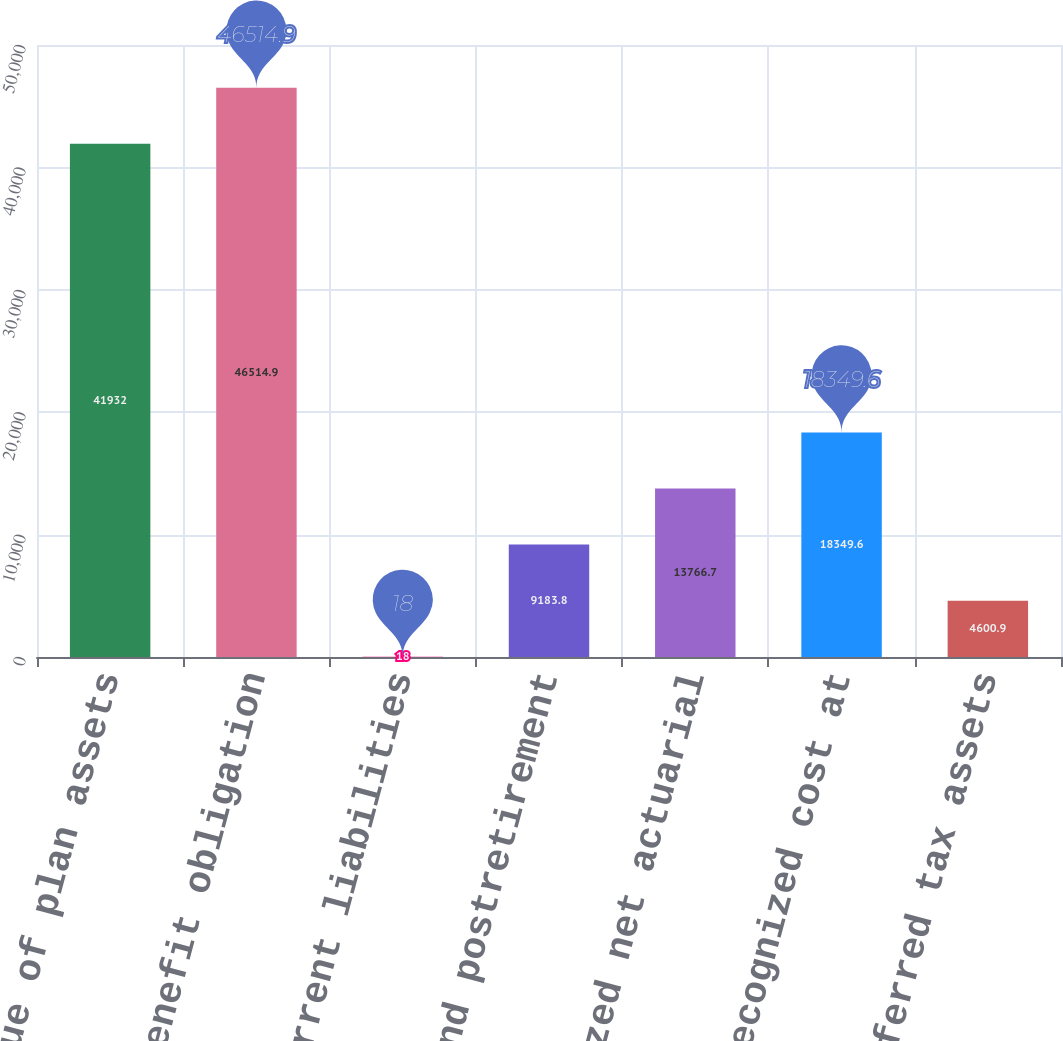Convert chart. <chart><loc_0><loc_0><loc_500><loc_500><bar_chart><fcel>Fair value of plan assets<fcel>Benefit obligation<fcel>Other current liabilities<fcel>Pension and postretirement<fcel>Unrecognized net actuarial<fcel>Gross unrecognized cost at<fcel>Deferred tax assets<nl><fcel>41932<fcel>46514.9<fcel>18<fcel>9183.8<fcel>13766.7<fcel>18349.6<fcel>4600.9<nl></chart> 